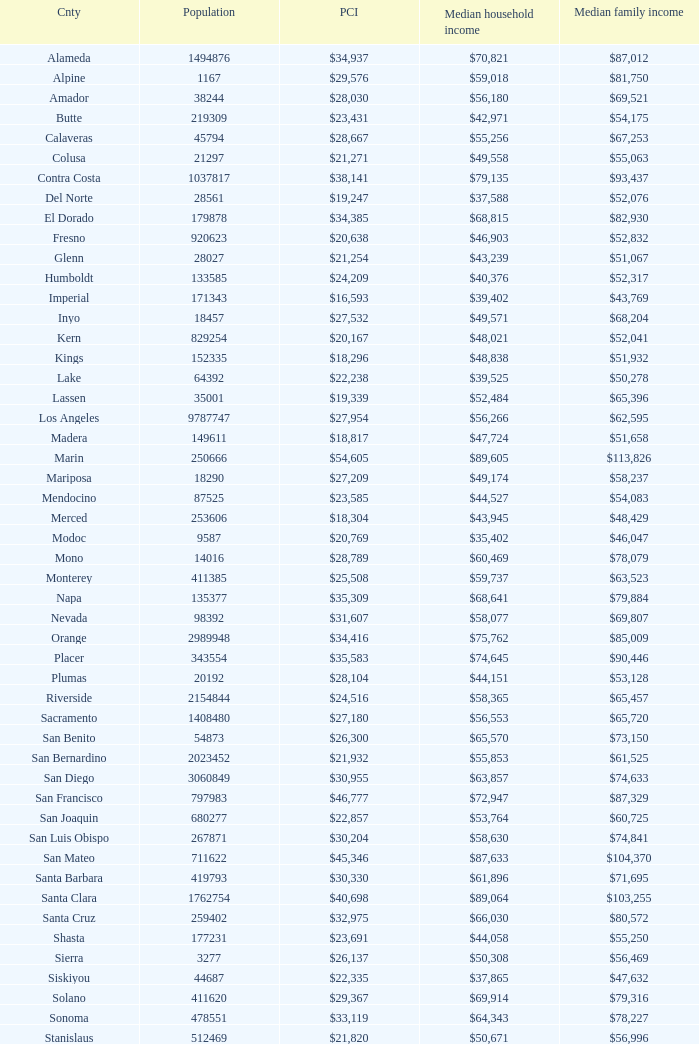What is the median household income of sacramento? $56,553. 